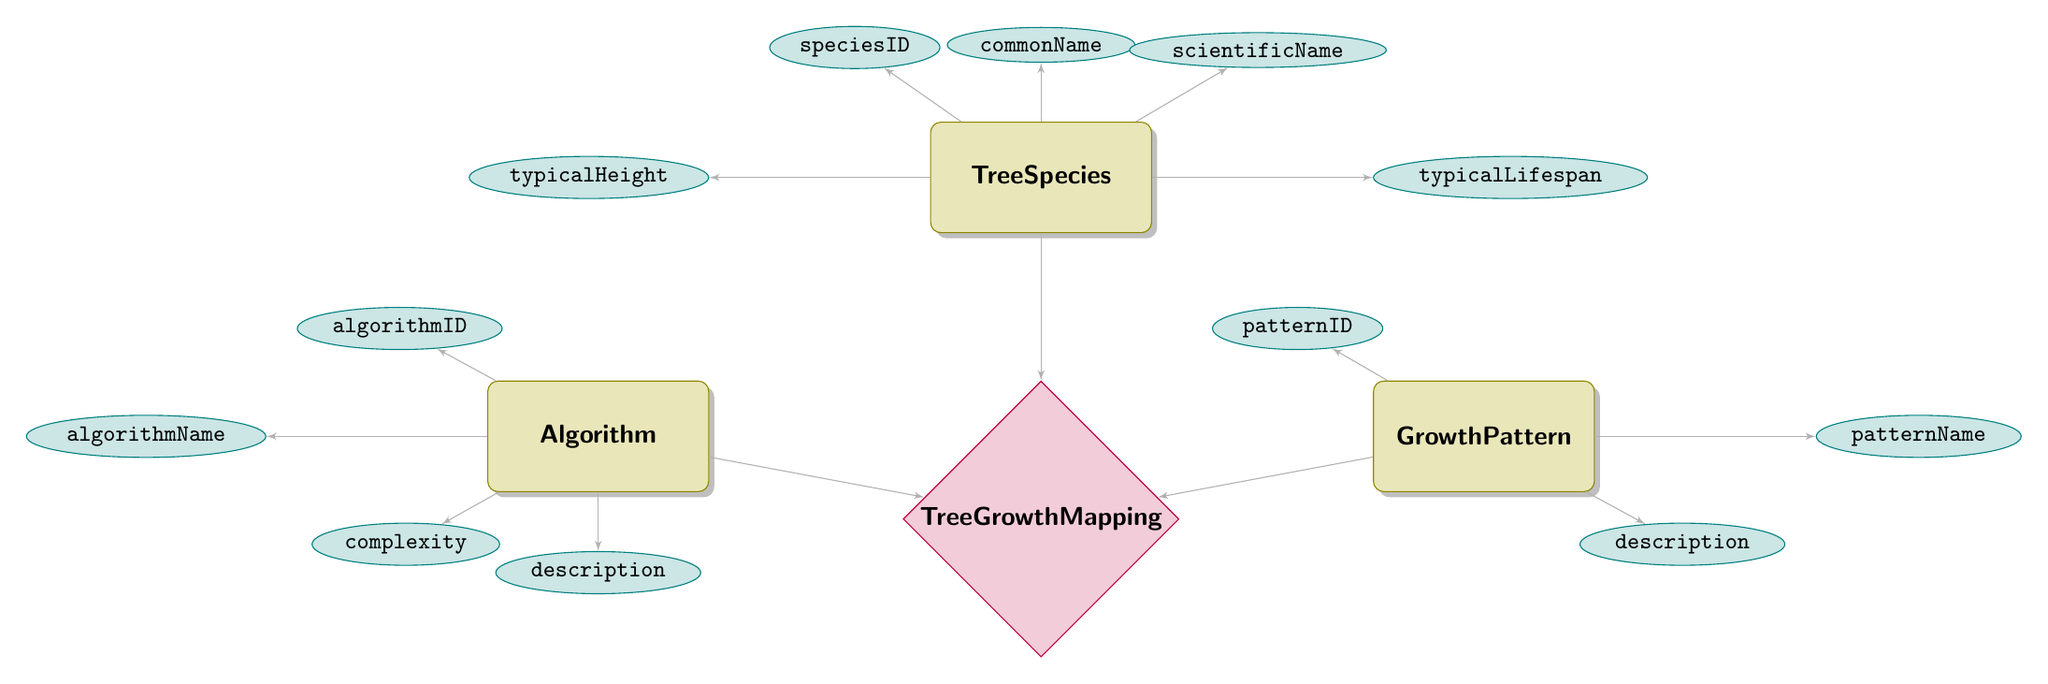What is the primary key of the TreeSpecies entity? The primary key of the TreeSpecies entity is speciesID, as stated in the diagram under its attributes section.
Answer: speciesID How many attributes does the Algorithm entity have? The Algorithm entity has four attributes: algorithmID, algorithmName, complexity, and description, which can be counted by referring to the attributes listed for this entity in the diagram.
Answer: 4 What relationship connects TreeSpecies to GrowthPattern? The relationship connecting TreeSpecies to GrowthPattern is represented by the Tree Growth Mapping relationship node, which indicates how the two entities interact.
Answer: Tree Growth Mapping What is the complexity of the Algorithm entity? The complexity attribute belongs to the Algorithm entity, and is specifically labeled as complexity in the attributes section of the diagram mapped under the Algorithm node.
Answer: complexity Which entity contains the description attribute? The description attribute is located under the GrowthPattern entity, as indicated by its listing in the attributes of that specific entity node.
Answer: GrowthPattern How many total entities are present in the diagram? The diagram includes four entities: TreeSpecies, GrowthPattern, Algorithm, and TreeGrowthMapping. The count can be confirmed by identifying each entity node distinctly in the diagram.
Answer: 4 What does the patternID attribute belong to? The patternID attribute is an attribute of the GrowthPattern entity, as indicated in the attributes section under that specific entity in the diagram.
Answer: GrowthPattern Name one attribute of the TreeSpecies entity. An example of an attribute of the TreeSpecies entity is commonName, which is listed among its attributes in the diagram.
Answer: commonName What is the primary key of the GrowthPattern entity? The primary key of the GrowthPattern entity is patternID, as specified in the attributes of the GrowthPattern entity in the diagram.
Answer: patternID 